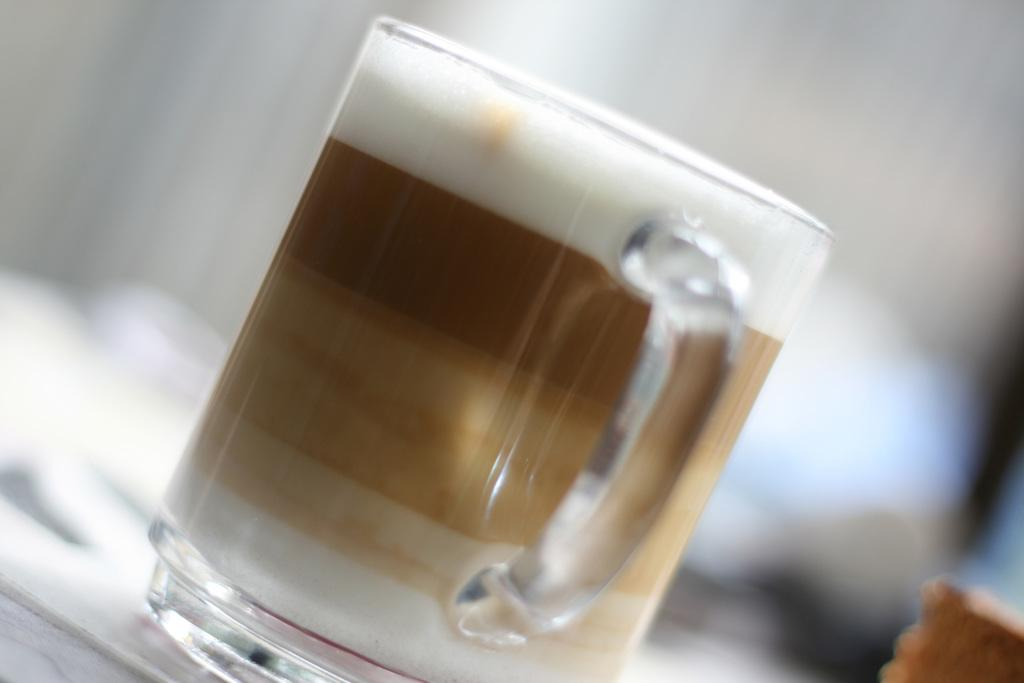What is the main object in the foreground of the image? There is a mug in the foreground of the image. What is the color of the surface on which the mug is placed? The mug is on a white surface. Can you describe the background of the image? The background of the image is blurred. What is the color and location of the object in the bottom right corner of the image? There is a brown-colored object in the right bottom corner of the image. How does the mug contribute to the discovery of a new species in the image? The image does not depict any discovery of a new species, and the mug is not related to such a discovery. 